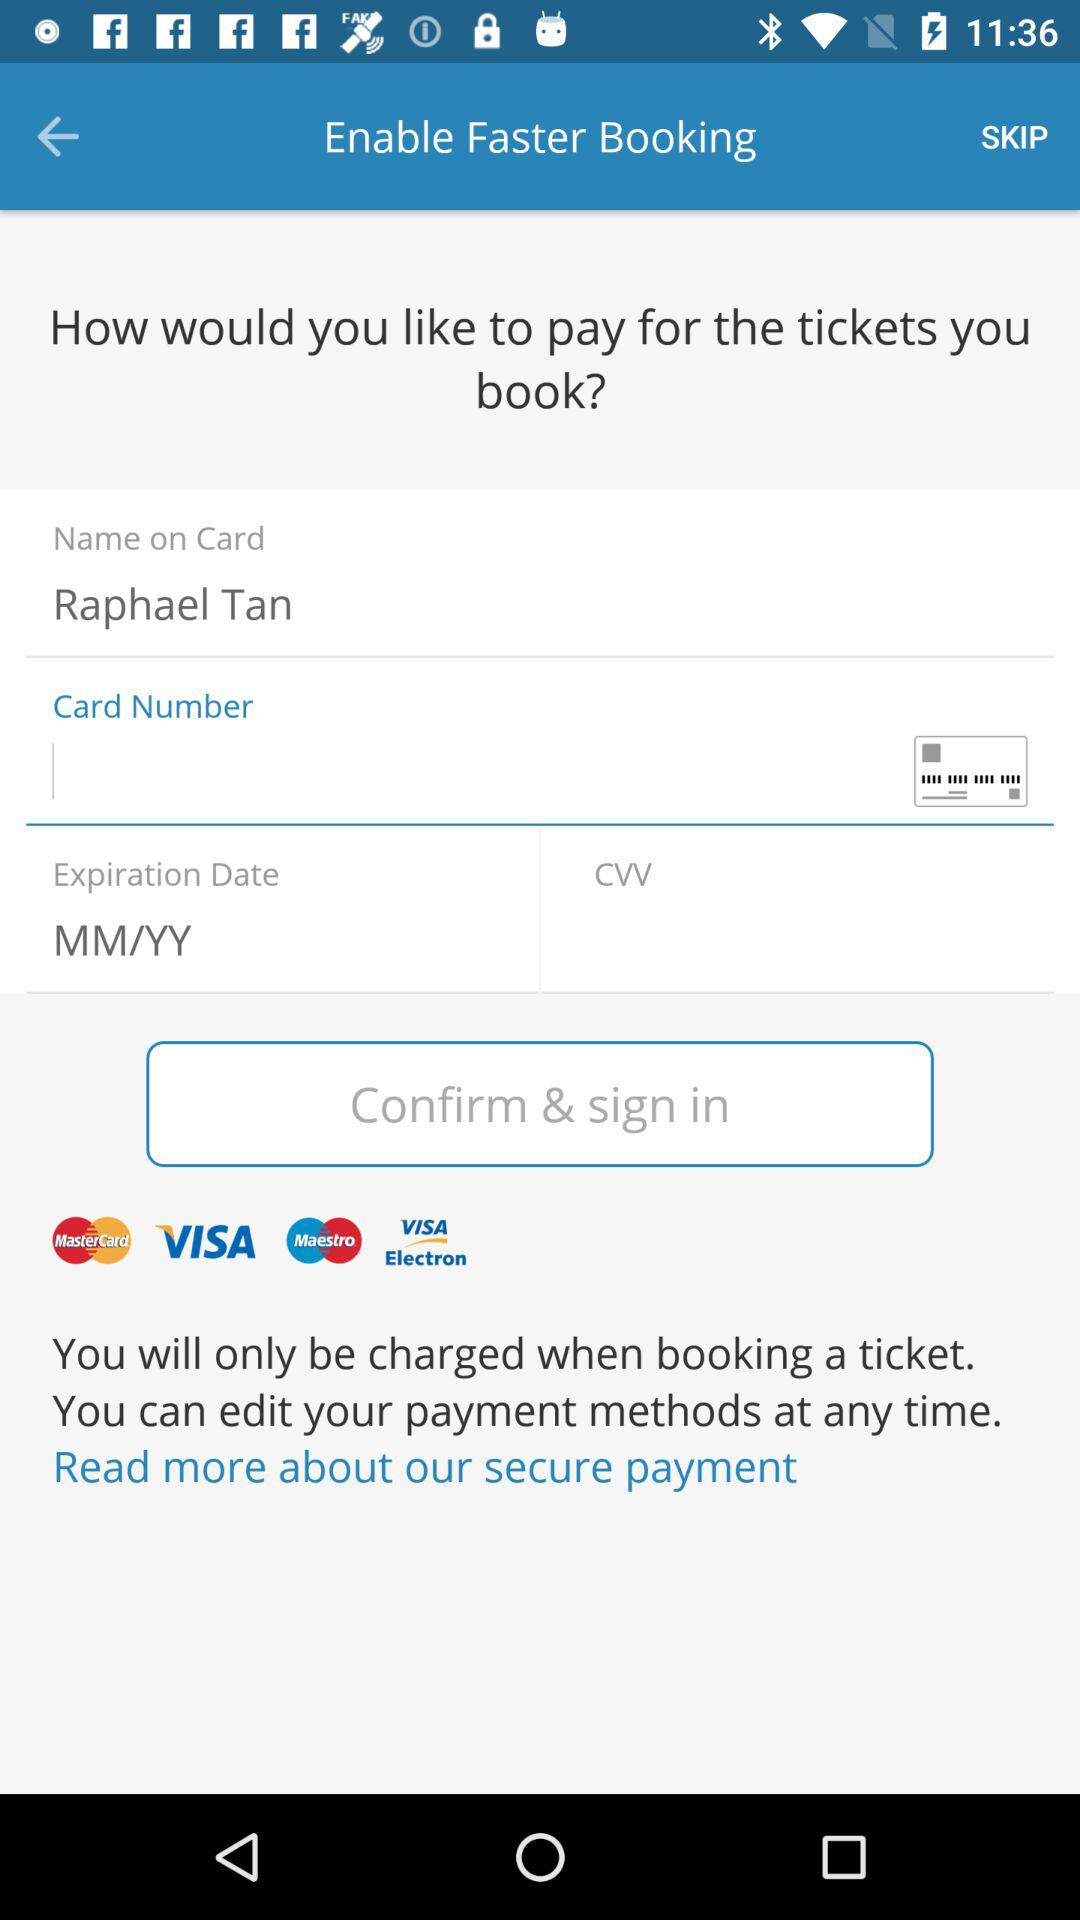What is the name of the user? The name of the user is Raphael Tan. 